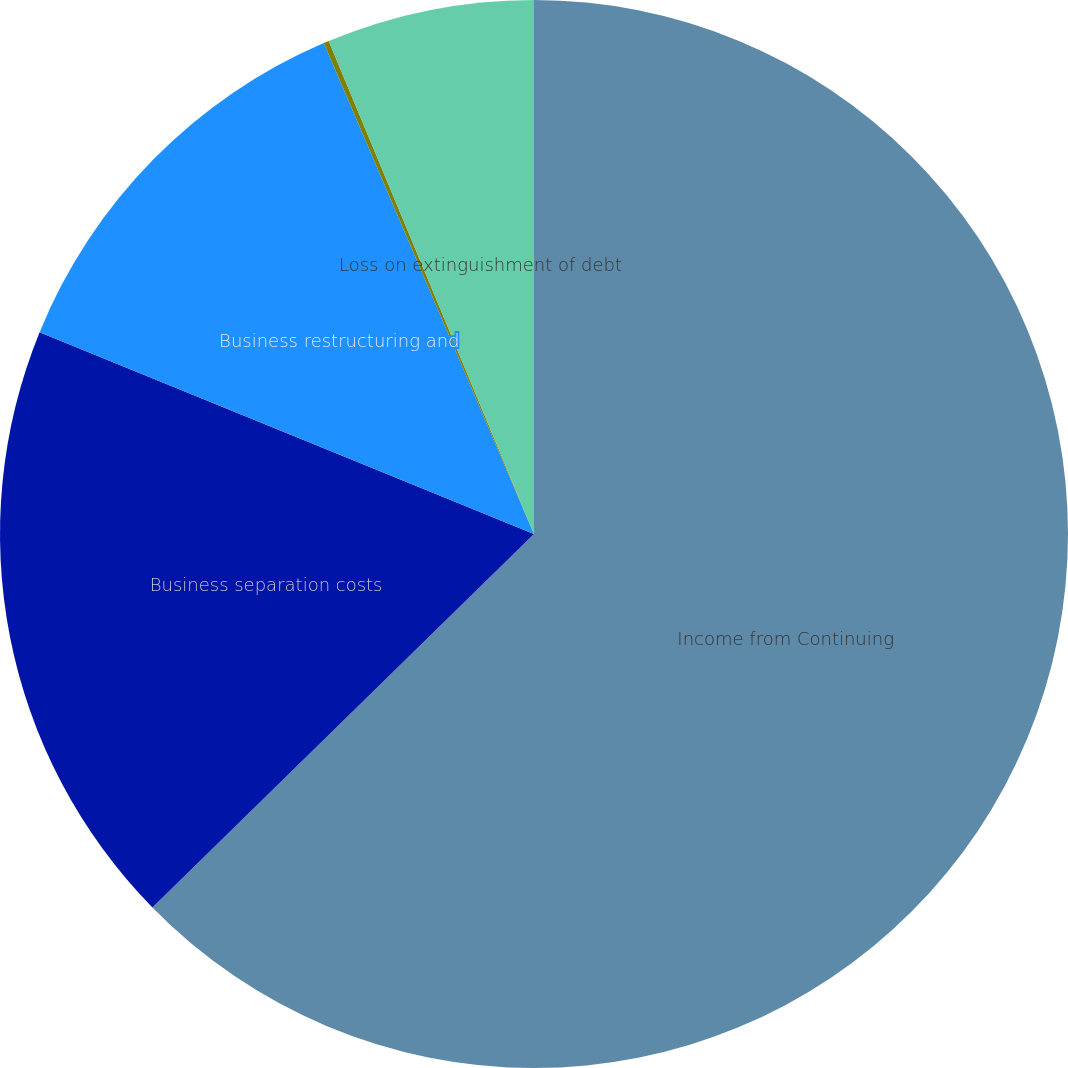Convert chart. <chart><loc_0><loc_0><loc_500><loc_500><pie_chart><fcel>Income from Continuing<fcel>Business separation costs<fcel>Business restructuring and<fcel>Pension settlement loss<fcel>Loss on extinguishment of debt<nl><fcel>62.67%<fcel>18.5%<fcel>12.39%<fcel>0.16%<fcel>6.28%<nl></chart> 